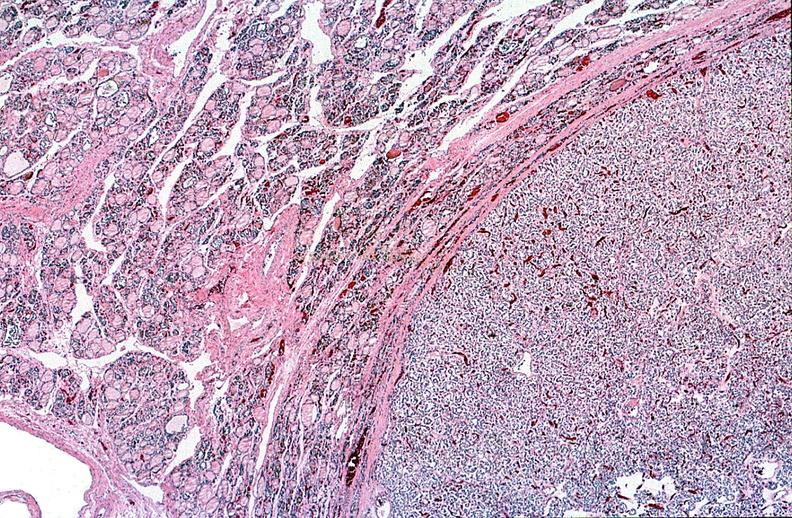s granulomata slide present?
Answer the question using a single word or phrase. No 